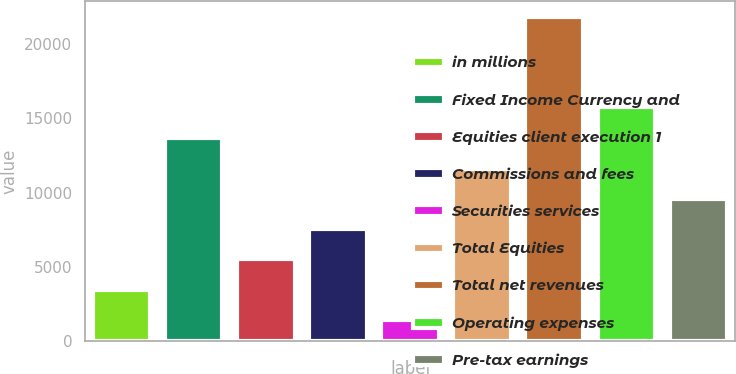<chart> <loc_0><loc_0><loc_500><loc_500><bar_chart><fcel>in millions<fcel>Fixed Income Currency and<fcel>Equities client execution 1<fcel>Commissions and fees<fcel>Securities services<fcel>Total Equities<fcel>Total net revenues<fcel>Operating expenses<fcel>Pre-tax earnings<nl><fcel>3468.4<fcel>13707<fcel>5504.8<fcel>7541.2<fcel>1432<fcel>11614<fcel>21796<fcel>15743.4<fcel>9577.6<nl></chart> 